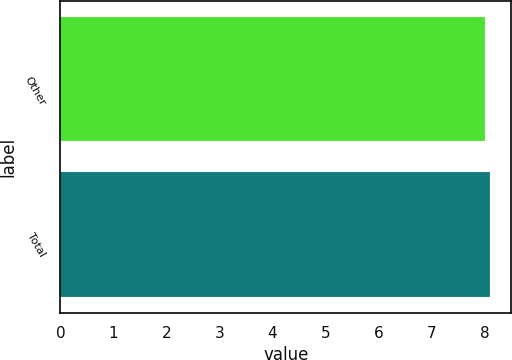Convert chart. <chart><loc_0><loc_0><loc_500><loc_500><bar_chart><fcel>Other<fcel>Total<nl><fcel>8<fcel>8.1<nl></chart> 